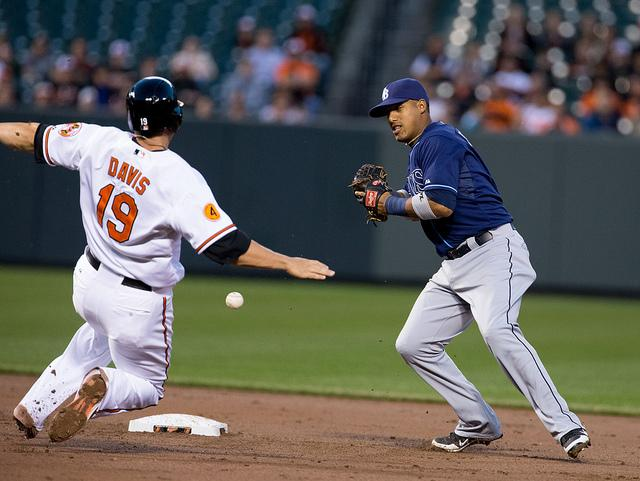What is 19 trying to do? Please explain your reasoning. touch base. Player #19 is going to slide so that he can reach the base safely before the other player catches the ball and tags him out. 